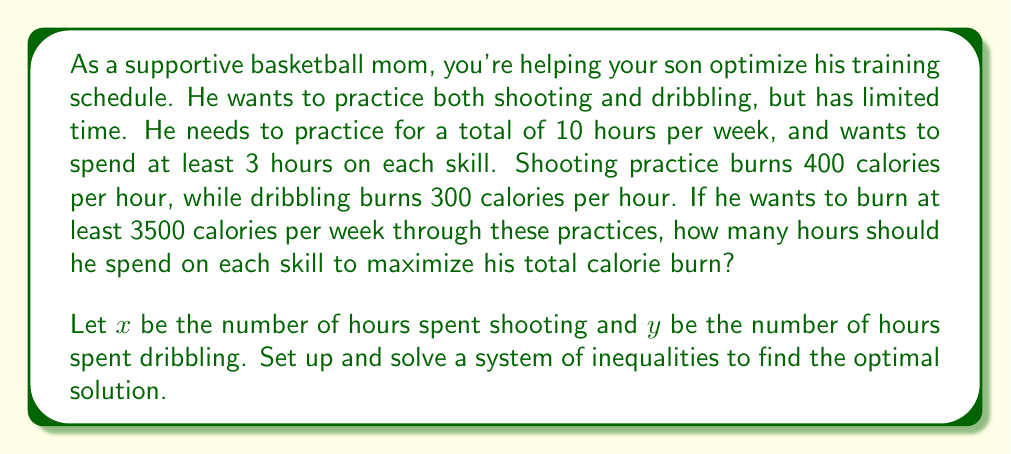Could you help me with this problem? Let's approach this step-by-step:

1) First, let's set up our system of inequalities based on the given information:

   $$\begin{cases}
   x + y = 10 \text{ (total practice time)}\\
   x \geq 3 \text{ (minimum shooting time)}\\
   y \geq 3 \text{ (minimum dribbling time)}\\
   400x + 300y \geq 3500 \text{ (calorie requirement)}
   \end{cases}$$

2) We want to maximize the total calorie burn, which is represented by the objective function:
   
   $$f(x,y) = 400x + 300y$$

3) From the first equation, we can express y in terms of x:
   
   $$y = 10 - x$$

4) Substituting this into our objective function:
   
   $$f(x) = 400x + 300(10-x) = 400x + 3000 - 300x = 100x + 3000$$

5) This shows that to maximize calorie burn, we should maximize x (shooting time), subject to our constraints.

6) The constraint $400x + 300y \geq 3500$ becomes:
   
   $$400x + 300(10-x) \geq 3500$$
   $$400x + 3000 - 300x \geq 3500$$
   $$100x \geq 500$$
   $$x \geq 5$$

7) Considering all constraints, x should be at least 5 and at most 7 (because y needs to be at least 3).

8) Therefore, the optimal solution is $x = 7$ and $y = 3$.
Answer: The optimal training schedule is 7 hours of shooting practice and 3 hours of dribbling practice per week. 